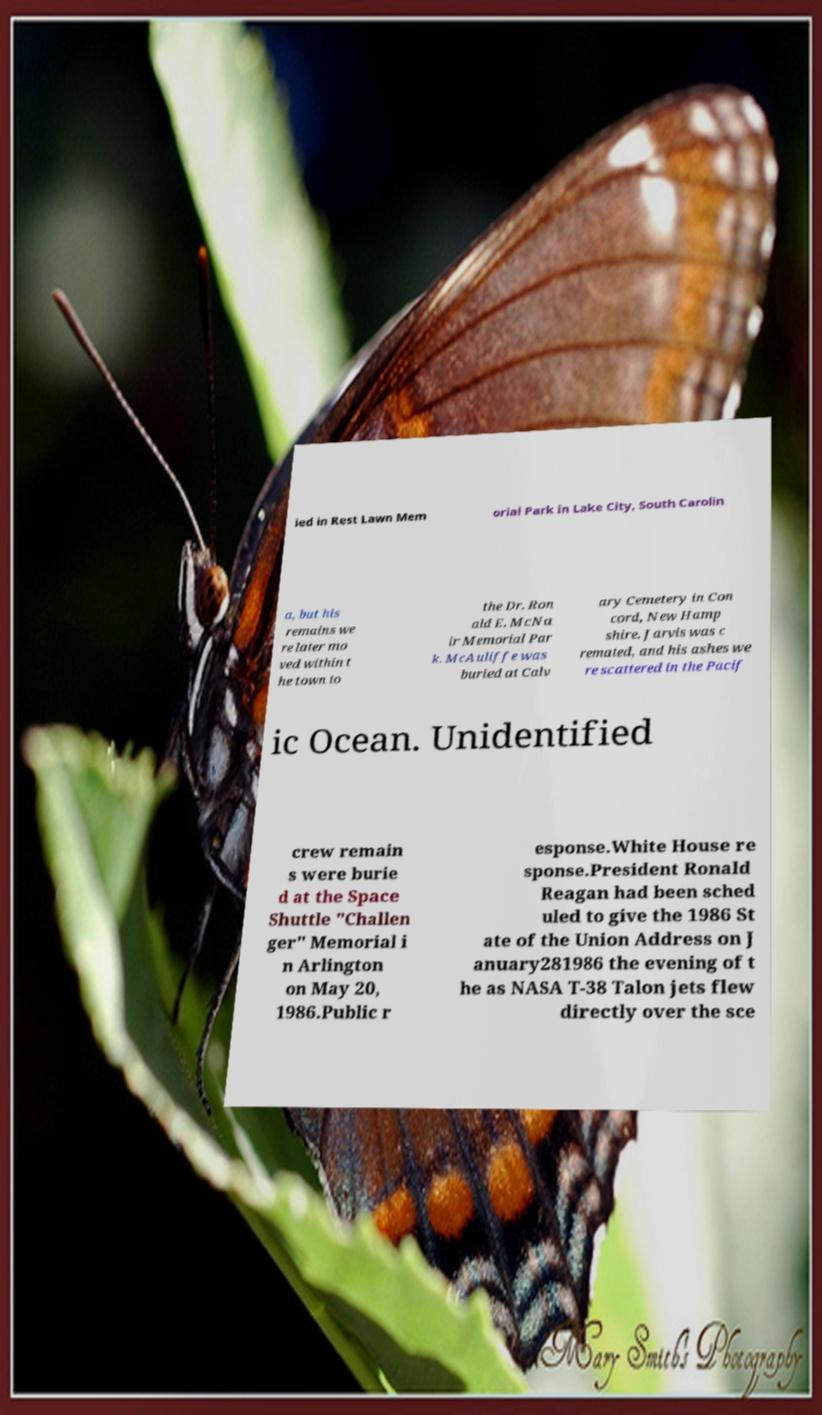Please read and relay the text visible in this image. What does it say? ied in Rest Lawn Mem orial Park in Lake City, South Carolin a, but his remains we re later mo ved within t he town to the Dr. Ron ald E. McNa ir Memorial Par k. McAuliffe was buried at Calv ary Cemetery in Con cord, New Hamp shire. Jarvis was c remated, and his ashes we re scattered in the Pacif ic Ocean. Unidentified crew remain s were burie d at the Space Shuttle "Challen ger" Memorial i n Arlington on May 20, 1986.Public r esponse.White House re sponse.President Ronald Reagan had been sched uled to give the 1986 St ate of the Union Address on J anuary281986 the evening of t he as NASA T-38 Talon jets flew directly over the sce 